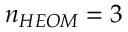<formula> <loc_0><loc_0><loc_500><loc_500>n _ { H E O M } = 3</formula> 